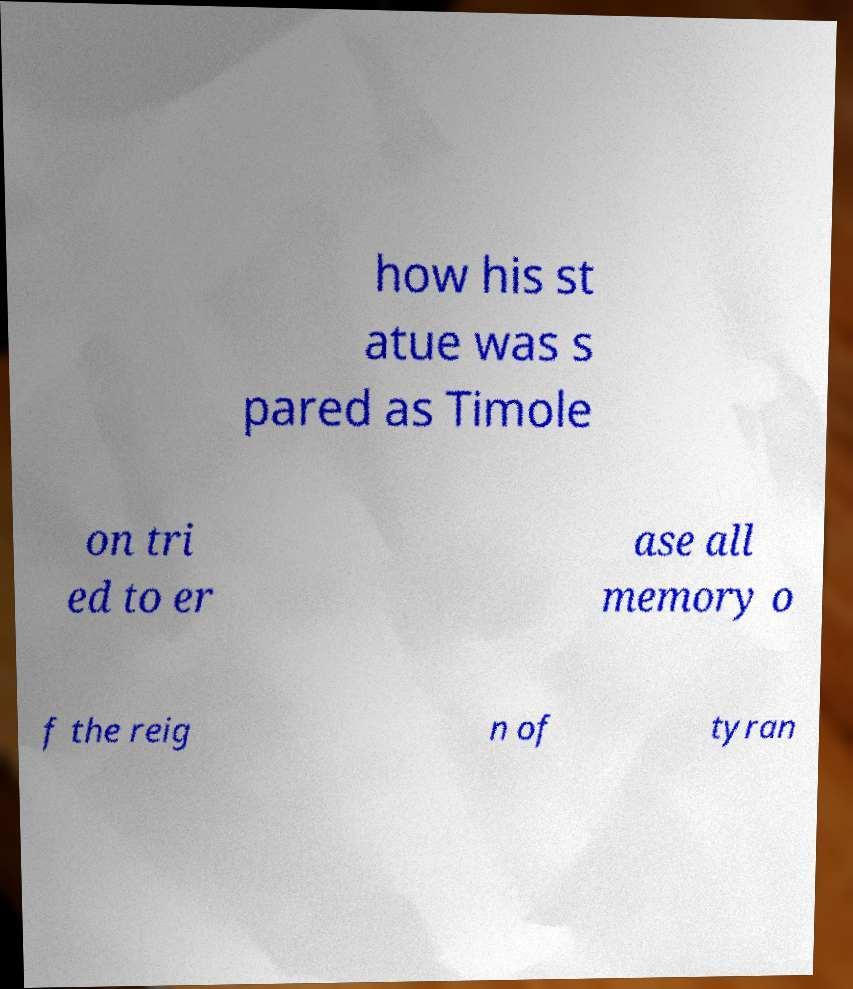Please read and relay the text visible in this image. What does it say? how his st atue was s pared as Timole on tri ed to er ase all memory o f the reig n of tyran 